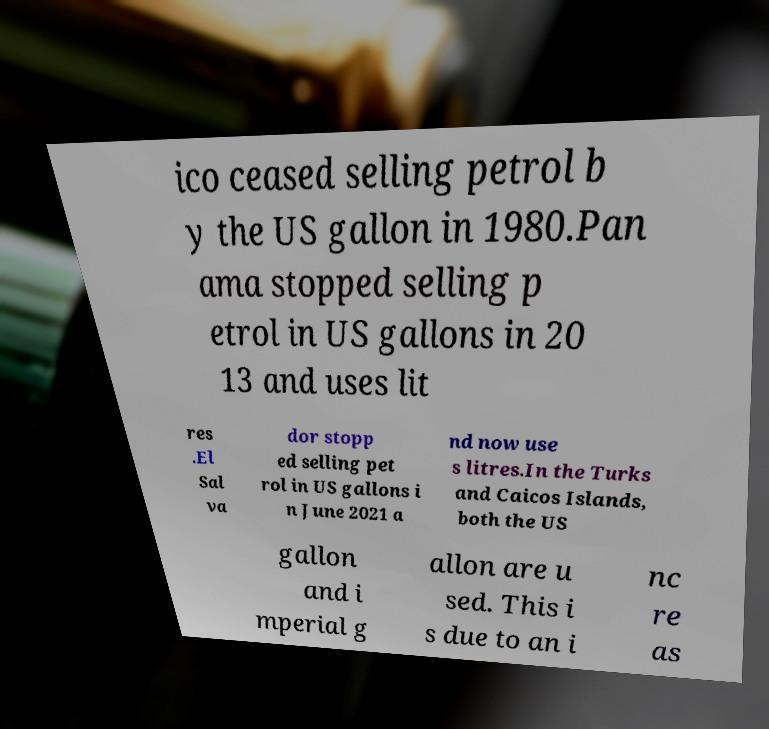There's text embedded in this image that I need extracted. Can you transcribe it verbatim? ico ceased selling petrol b y the US gallon in 1980.Pan ama stopped selling p etrol in US gallons in 20 13 and uses lit res .El Sal va dor stopp ed selling pet rol in US gallons i n June 2021 a nd now use s litres.In the Turks and Caicos Islands, both the US gallon and i mperial g allon are u sed. This i s due to an i nc re as 